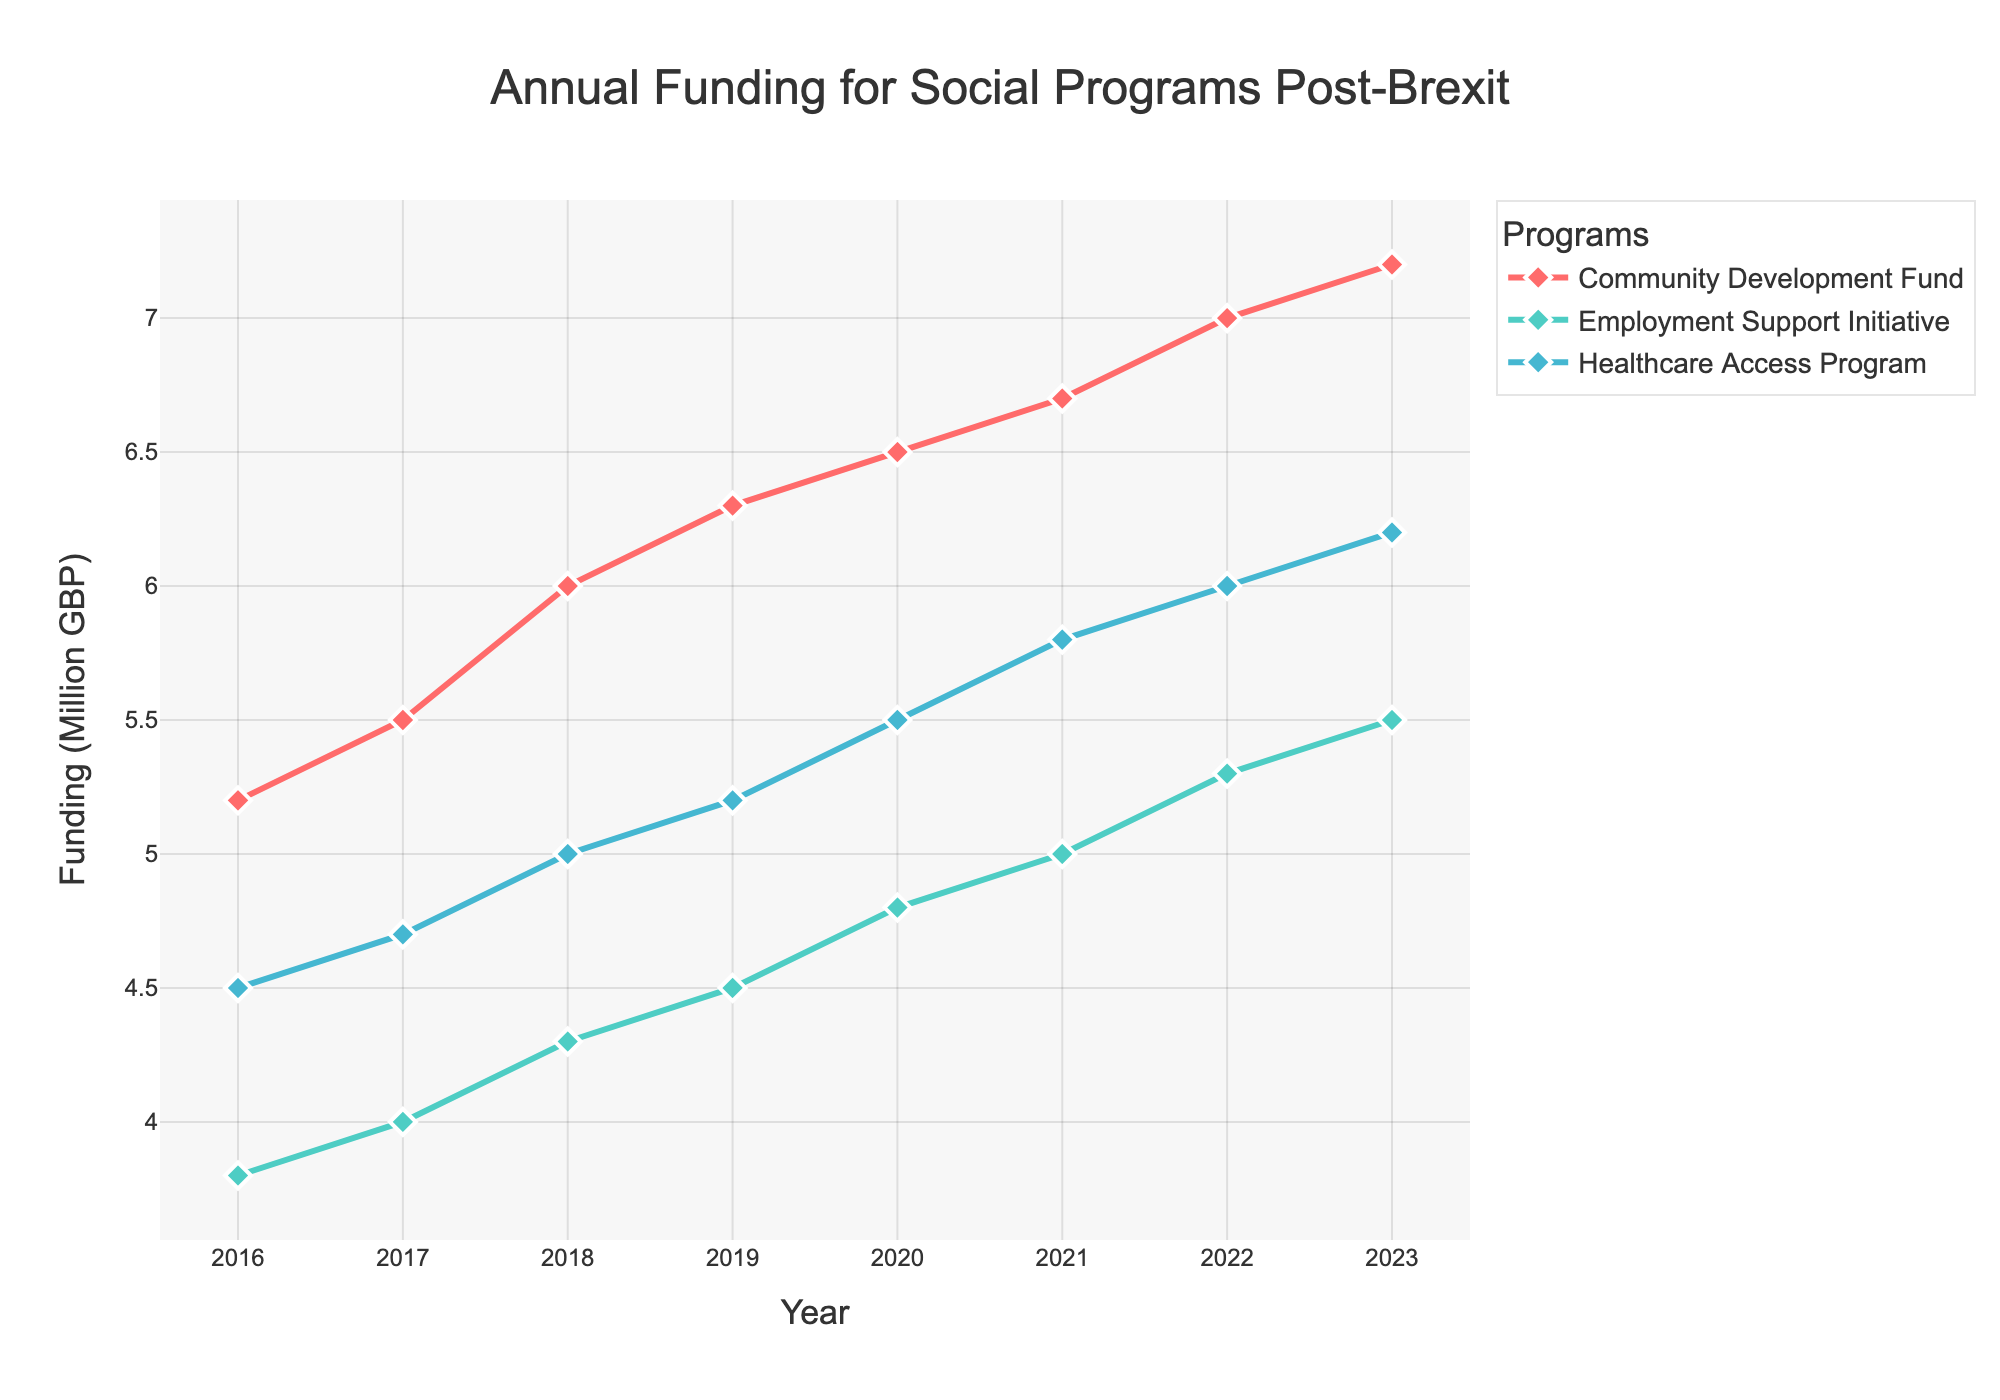What is the title of the figure? The title is typically located at the top of the figure. Here, it reads "Annual Funding for Social Programs Post-Brexit"
Answer: Annual Funding for Social Programs Post-Brexit What is the funding amount in 2017 for the Employment Support Initiative? Find the data point for "Employment Support Initiative" in the year 2017 on the plot and read the funding value. It shows £4M
Answer: £4M Which program received the highest funding in 2023? Locate the data points for 2023 and compare the funding values for each program. The "Community Development Fund" has the highest funding at £7.2M
Answer: Community Development Fund How did the funding for the Healthcare Access Program change from 2016 to 2023? Note the funding values for "Healthcare Access Program" in 2016 and 2023 and calculate the change. From £4.5M in 2016 to £6.2M in 2023, the funding increased
Answer: Increased by £1.7M What is the trend of the Community Development Fund from 2016 to 2023? Observe the line representing "Community Development Fund" from 2016 to 2023; it shows a consistent upward trend
Answer: Upward trend What is the average annual funding for the Employment Support Initiative between 2016 and 2023? Sum the funding amounts for each year from 2016 to 2023 for "Employment Support Initiative" (£3.8M + £4M + £4.3M + £4.5M + £4.8M + £5M + £5.3M + £5.5M = £37.2M). Then, divide by the number of years (8): £37.2M / 8 ≈ £4.65M
Answer: £4.65M Compare the funding of the Community Development Fund and Healthcare Access Program in 2021. Which was higher and by how much? Find the funding amounts for 2021 for both programs. Community Development Fund: £6.7M and Healthcare Access Program: £5.8M. The difference is £6.7M - £5.8M = £0.9M
Answer: Community Development Fund by £0.9M Between which consecutive years did the Employment Support Initiative see its highest increase in funding? Analyze year-on-year funding changes for the Employment Support Initiative. The highest increase is from 2021 (£5.0M) to 2022 (£5.3M), a change of £0.3M
Answer: 2021-2022 What is the total funding across all programs in 2020? Sum the funding for all programs in 2020: Community Development Fund (£6.5M) + Employment Support Initiative (£4.8M) + Healthcare Access Program (£5.5M). So, £6.5M + £4.8M + £5.5M = £16.8M
Answer: £16.8M Has the funding for any program decreased over any year? If yes, specify the program and the year(s). Upon review, funding for all programs either increased or stayed the same over the years. No program experienced a decrease
Answer: No 